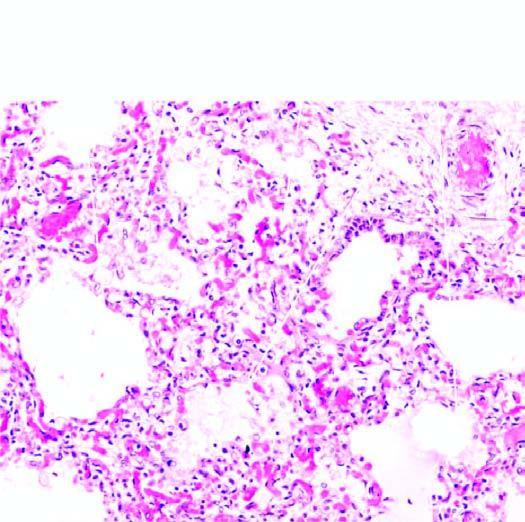what contain pale oedema fluid and a few red cells?
Answer the question using a single word or phrase. The air spaces 